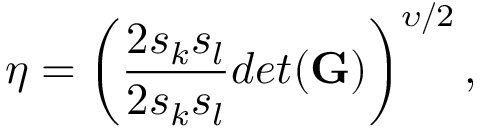<formula> <loc_0><loc_0><loc_500><loc_500>\eta = \left ( \frac { 2 s _ { k } s _ { l } } { 2 s _ { k } s _ { l } } { d e t ( G ) } \right ) ^ { \upsilon / 2 } ,</formula> 